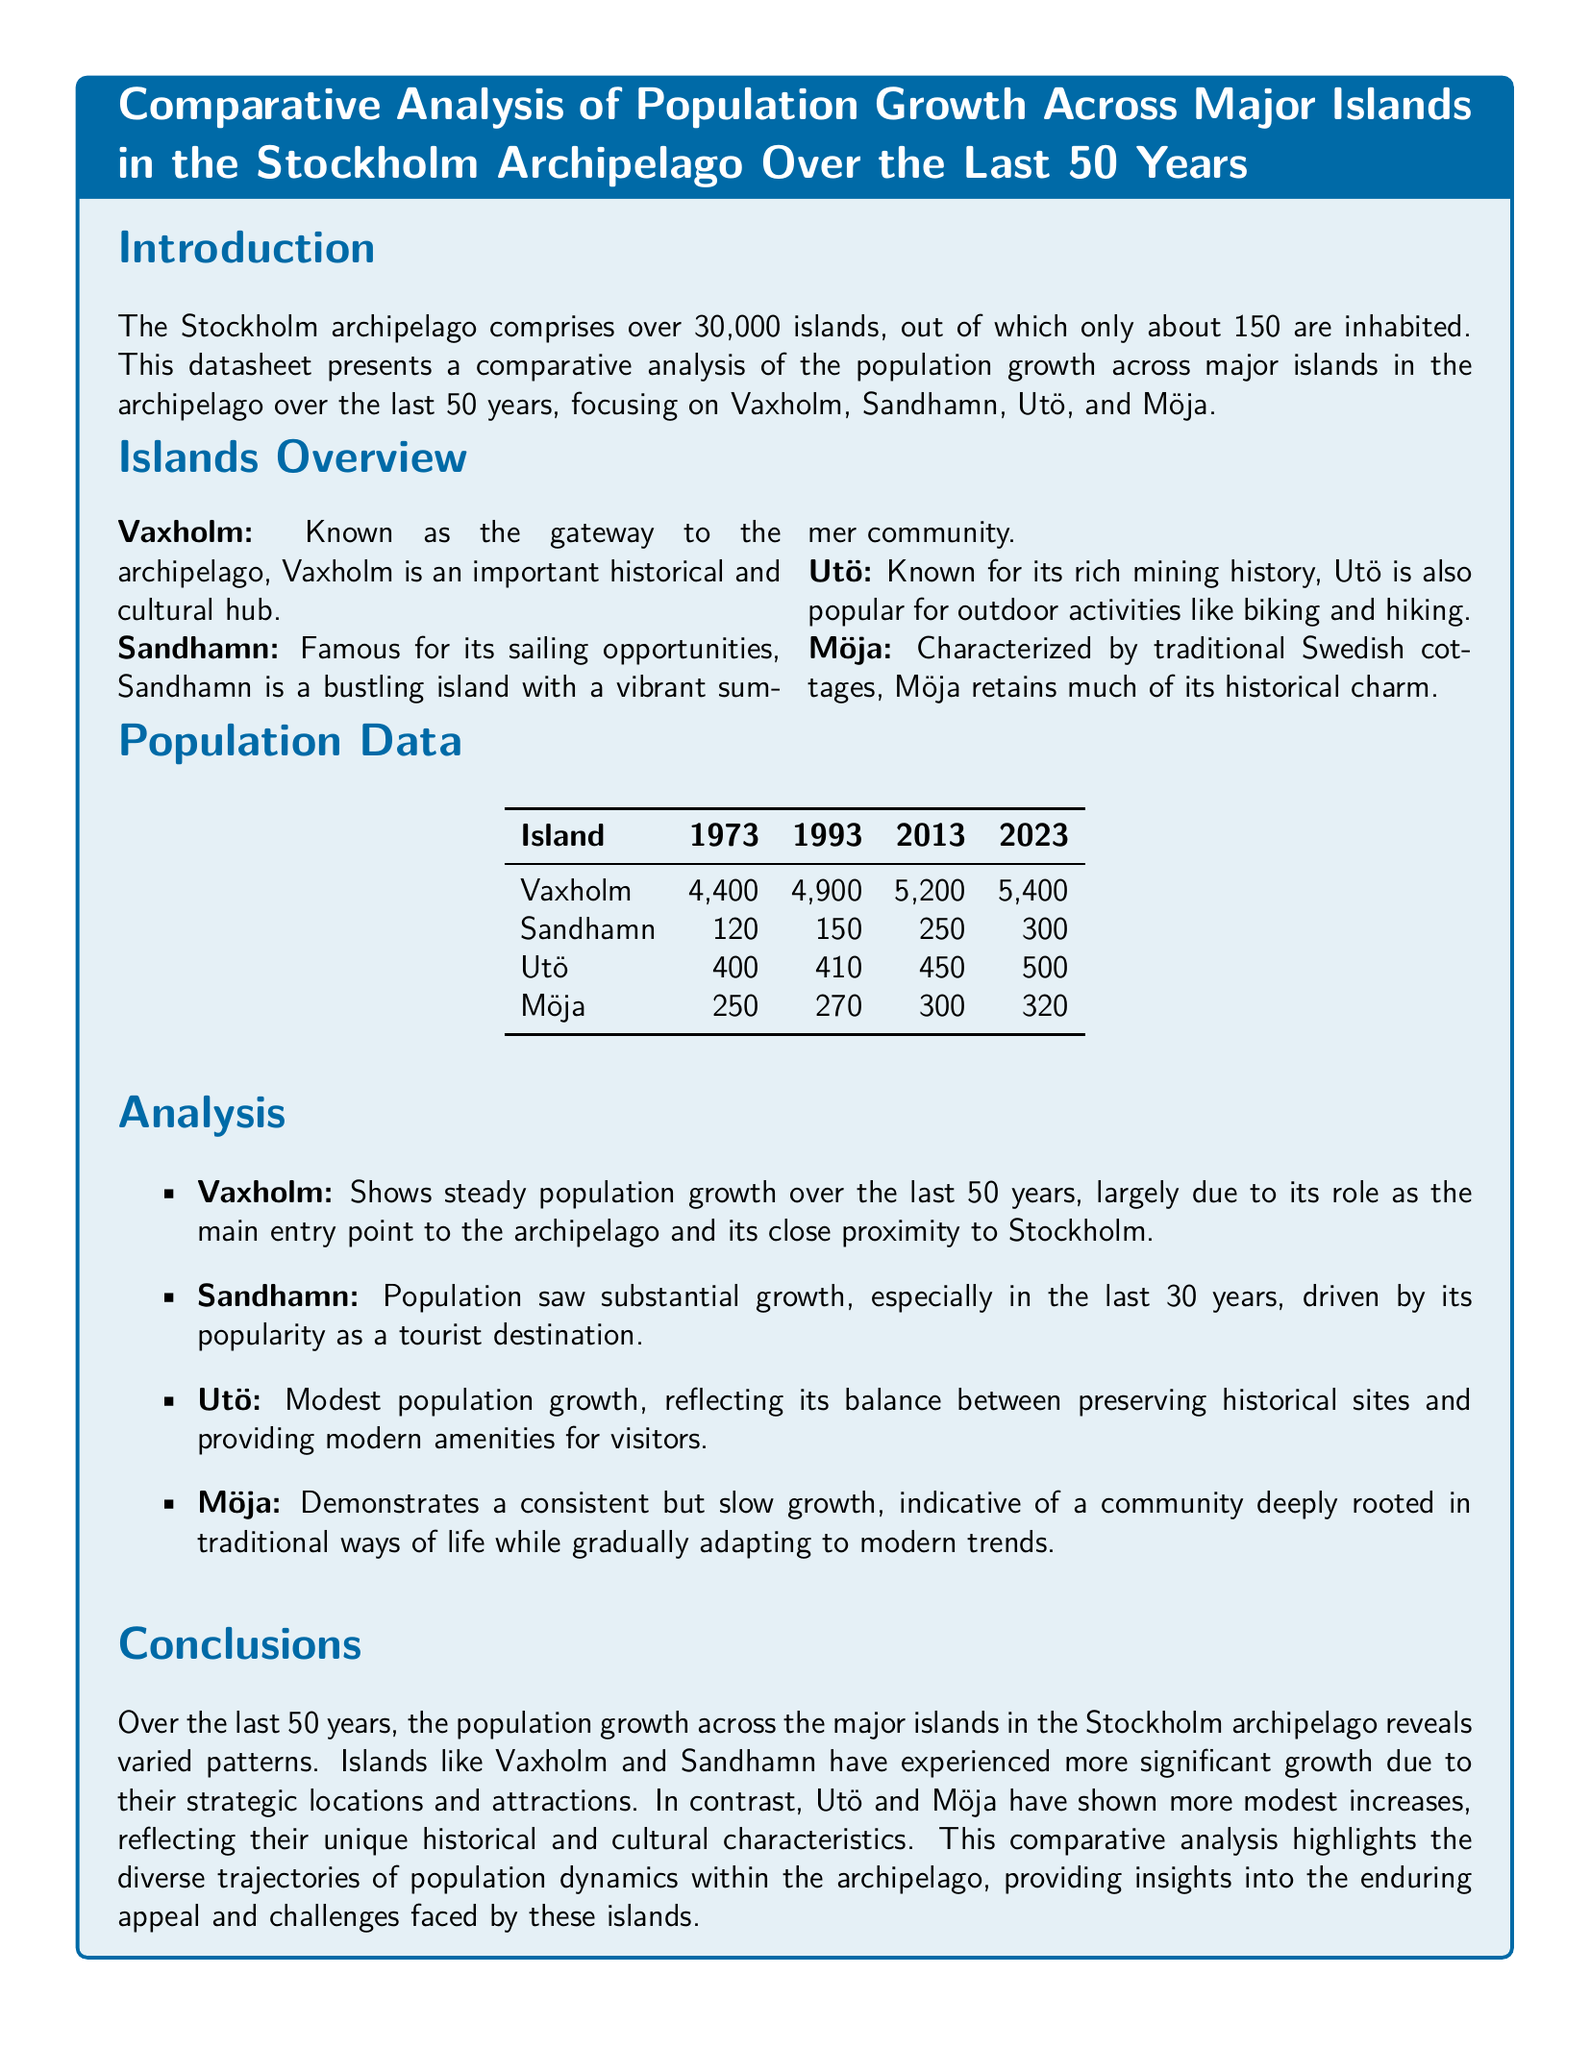what is the population of Vaxholm in 2023? The population of Vaxholm in 2023 is directly referenced in the population data section of the document.
Answer: 5400 what is the population of Sandhamn in 1973? The population of Sandhamn in 1973 is explicitly stated in the population data table.
Answer: 120 which island experienced the most significant population growth? The analysis section discusses population growth across various islands, indicating which saw the most substantial increase.
Answer: Sandhamn how many inhabited islands are there in the Stockholm archipelago? The introduction section mentions the total number of inhabited islands in the archipelago.
Answer: 150 what is the population of Möja in 2013? The population data table provides specific population numbers for Möja across different years, including 2013.
Answer: 300 what historical aspect is associated with Utö? The overview section describes the distinctive characteristics of Utö, including its historical relevance.
Answer: Mining history what trend is observed for the population of Möja over the last 50 years? The analysis section reflects on the population growth patterns for Möja over time, indicating its trend.
Answer: Slow growth how has Vaxholm's role contributed to its population growth? The analysis section provides a direct explanation of factors contributing to Vaxholm's population increase.
Answer: Gateway to the archipelago what major factor influences Sandhamn's population growth? The analysis section highlights a key reason behind Sandhamn's population changes over the years.
Answer: Tourist destination 